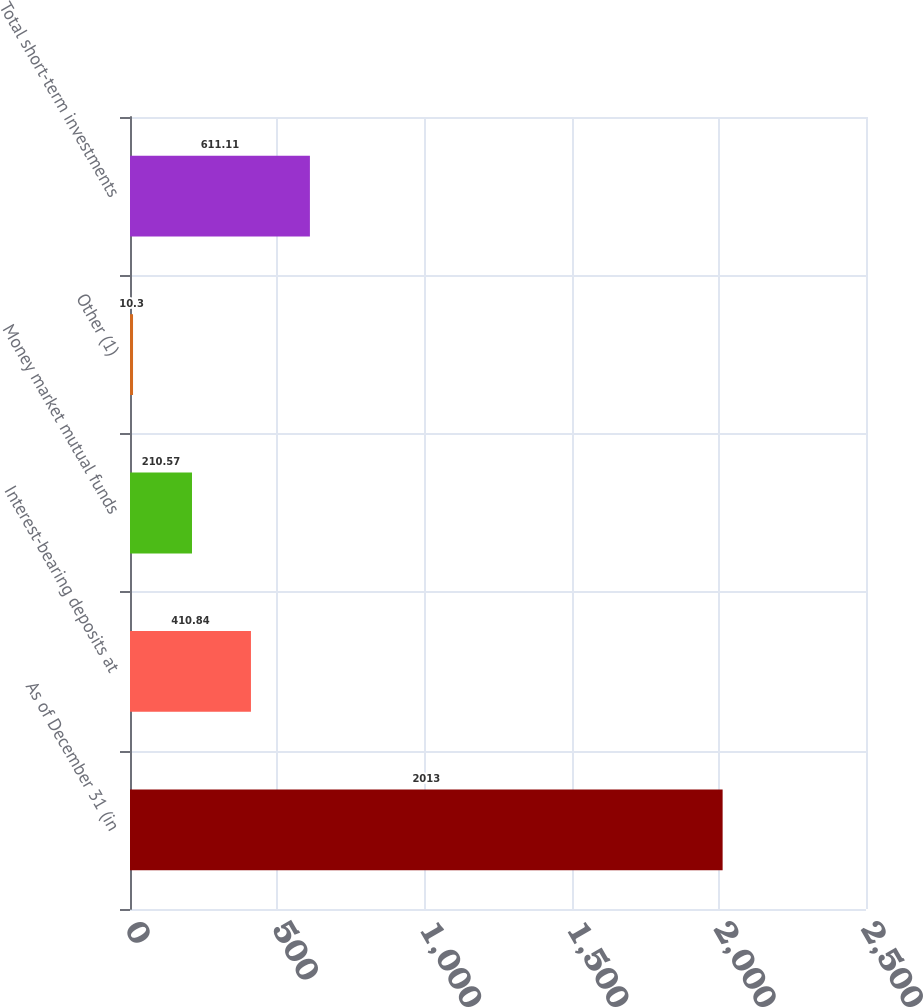Convert chart to OTSL. <chart><loc_0><loc_0><loc_500><loc_500><bar_chart><fcel>As of December 31 (in<fcel>Interest-bearing deposits at<fcel>Money market mutual funds<fcel>Other (1)<fcel>Total short-term investments<nl><fcel>2013<fcel>410.84<fcel>210.57<fcel>10.3<fcel>611.11<nl></chart> 